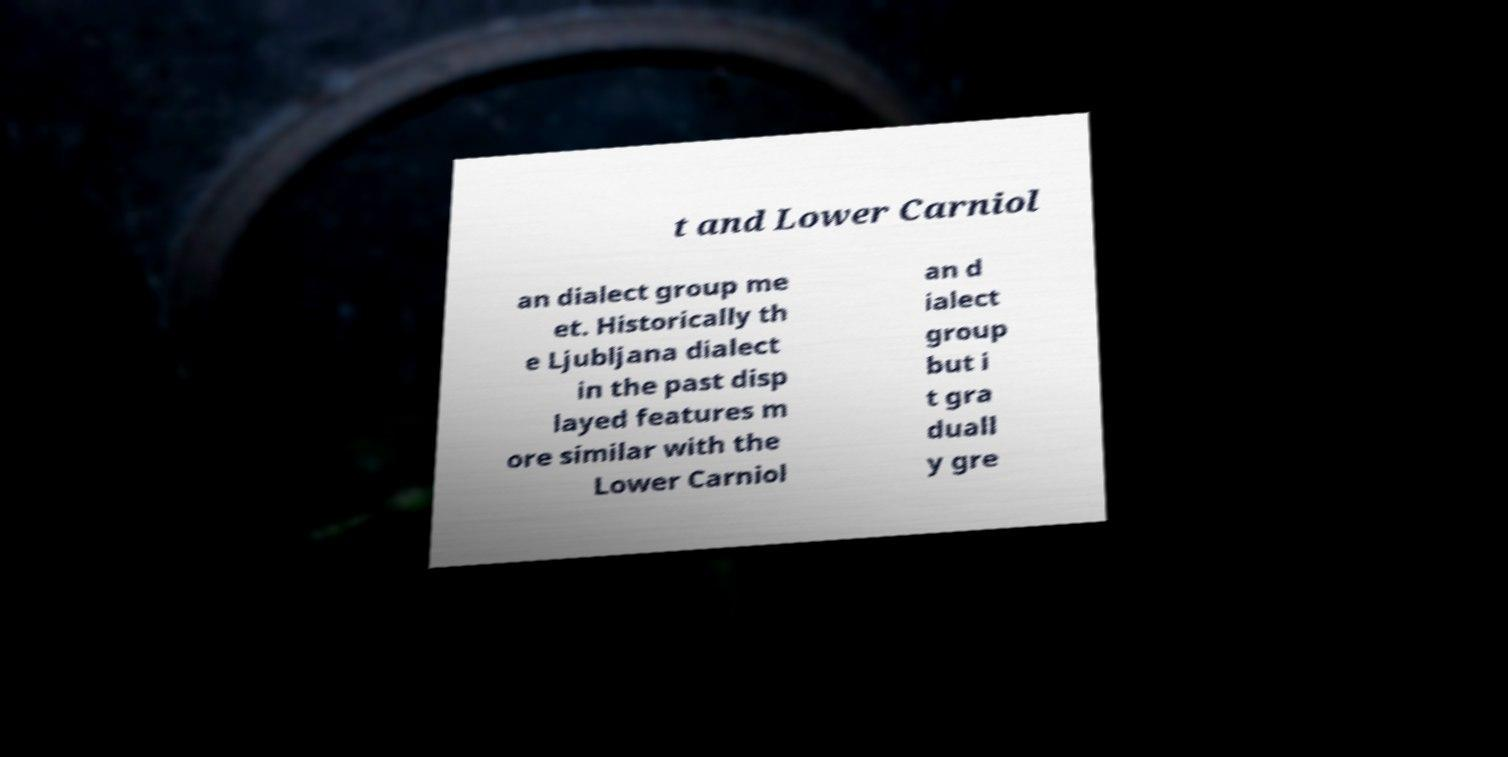Please identify and transcribe the text found in this image. t and Lower Carniol an dialect group me et. Historically th e Ljubljana dialect in the past disp layed features m ore similar with the Lower Carniol an d ialect group but i t gra duall y gre 